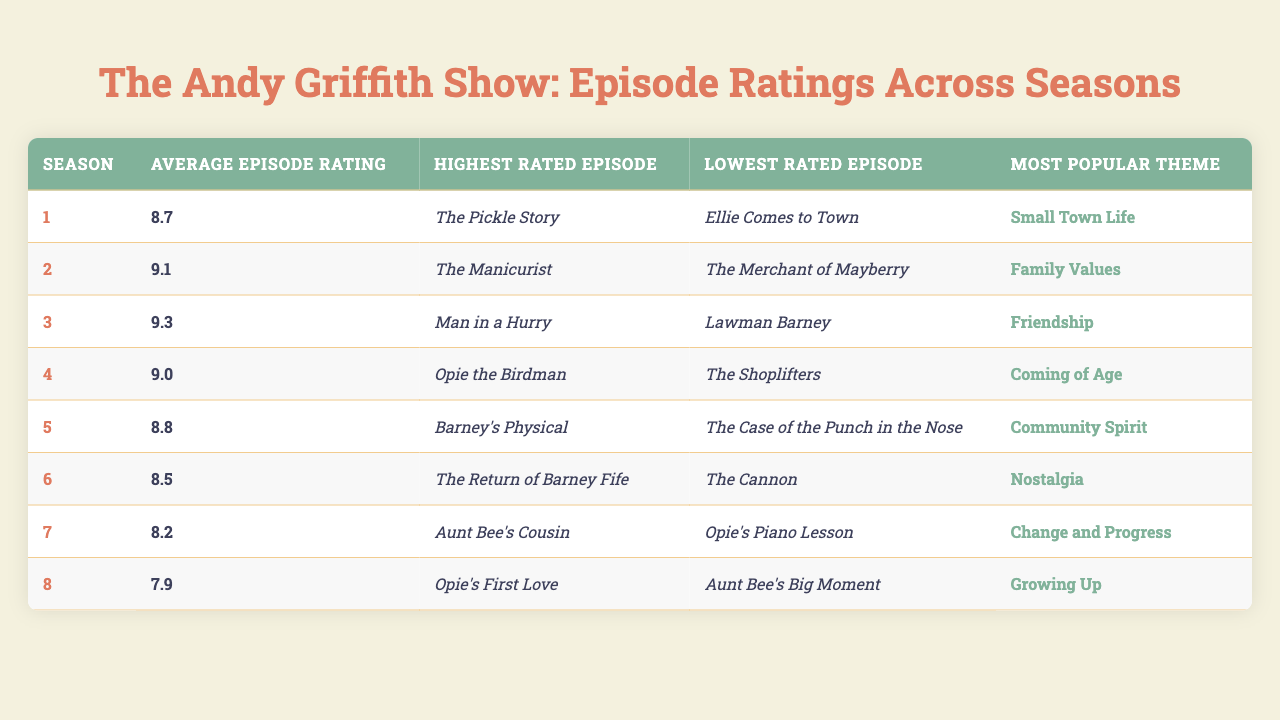What is the highest rated episode in Season 3? According to the table, the highest rated episode in Season 3 is "Man in a Hurry."
Answer: Man in a Hurry Which season has the lowest average episode rating? By looking at the average episode ratings, Season 8 has the lowest average rating of 7.9.
Answer: 7.9 What is the most popular theme for Season 5? The table indicates that the most popular theme for Season 5 is "Community Spirit."
Answer: Community Spirit How does the average rating of Season 2 compare to Season 4? Season 2 has an average rating of 9.1, while Season 4 has an average rating of 9.0. Season 2 has a higher average rating than Season 4 by 0.1 points.
Answer: 0.1 True or False: "Aunt Bee's Cousin" is the highest rated episode in Season 7. The table shows that "Aunt Bee's Cousin" is the highest rated episode in Season 7, confirming that this statement is true.
Answer: True What is the difference in average ratings between Season 1 and Season 6? The average rating for Season 1 is 8.7, while for Season 6 it is 8.5. The difference is 8.7 - 8.5 = 0.2.
Answer: 0.2 Which season features "Opie the Birdman" as the highest rated episode? The table reveals that "Opie the Birdman" is the highest rated episode in Season 4.
Answer: Season 4 If we consider only Seasons 2 to 4, what is the average of their average ratings? For Seasons 2 (9.1), 3 (9.3), and 4 (9.0), the sum is 9.1 + 9.3 + 9.0 = 27.4. Dividing by 3 gives an average of 27.4 / 3 = 9.133, rounding it gives approximately 9.1.
Answer: 9.1 What episode has the lowest rating in Season 5? According to the table, the lowest rated episode in Season 5 is "The Case of the Punch in the Nose."
Answer: The Case of the Punch in the Nose Which season has the most popular theme of "Growing Up"? "Growing Up" is identified as the most popular theme in Season 8, according to the table.
Answer: Season 8 